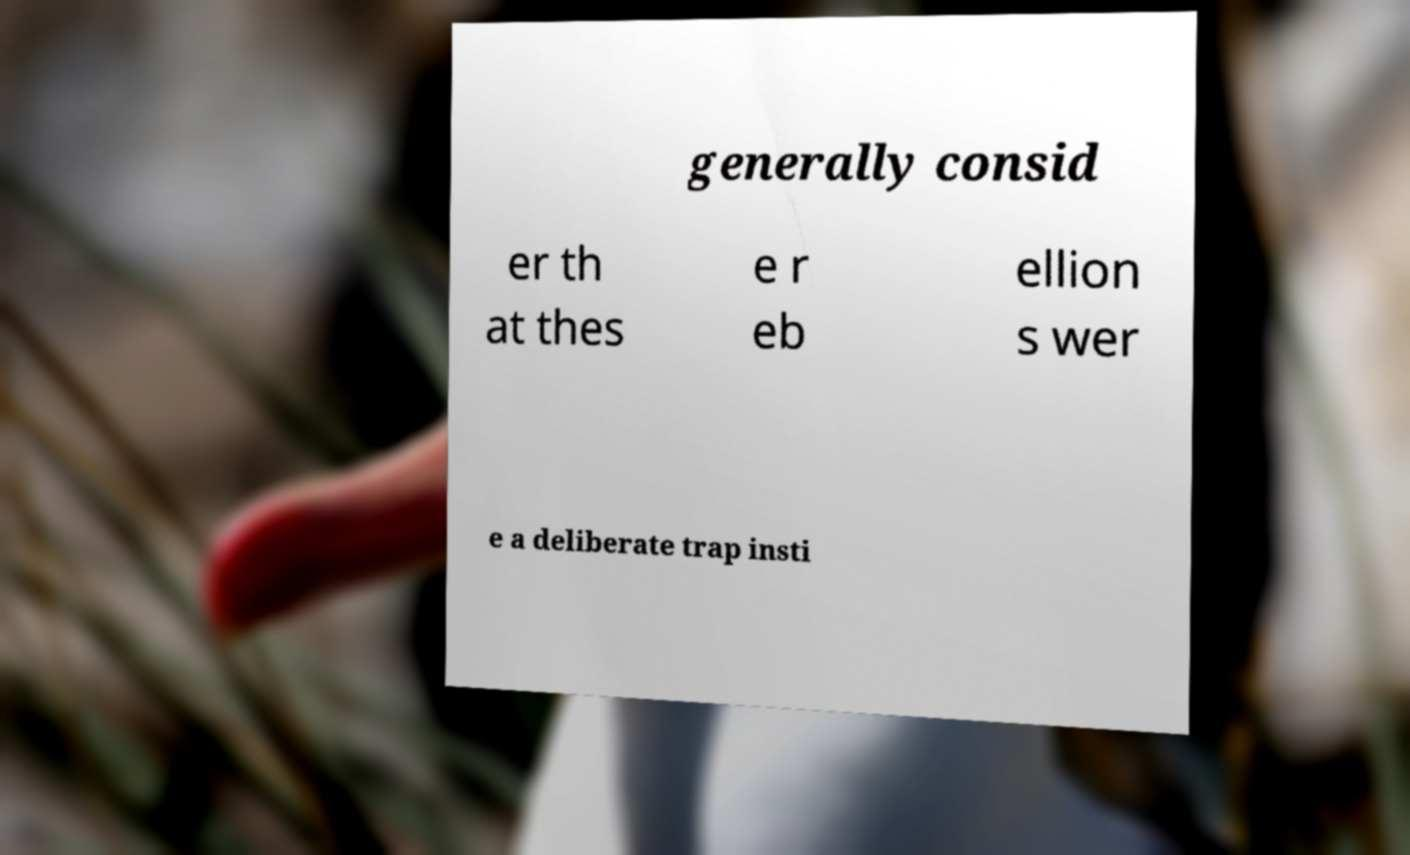Can you accurately transcribe the text from the provided image for me? generally consid er th at thes e r eb ellion s wer e a deliberate trap insti 